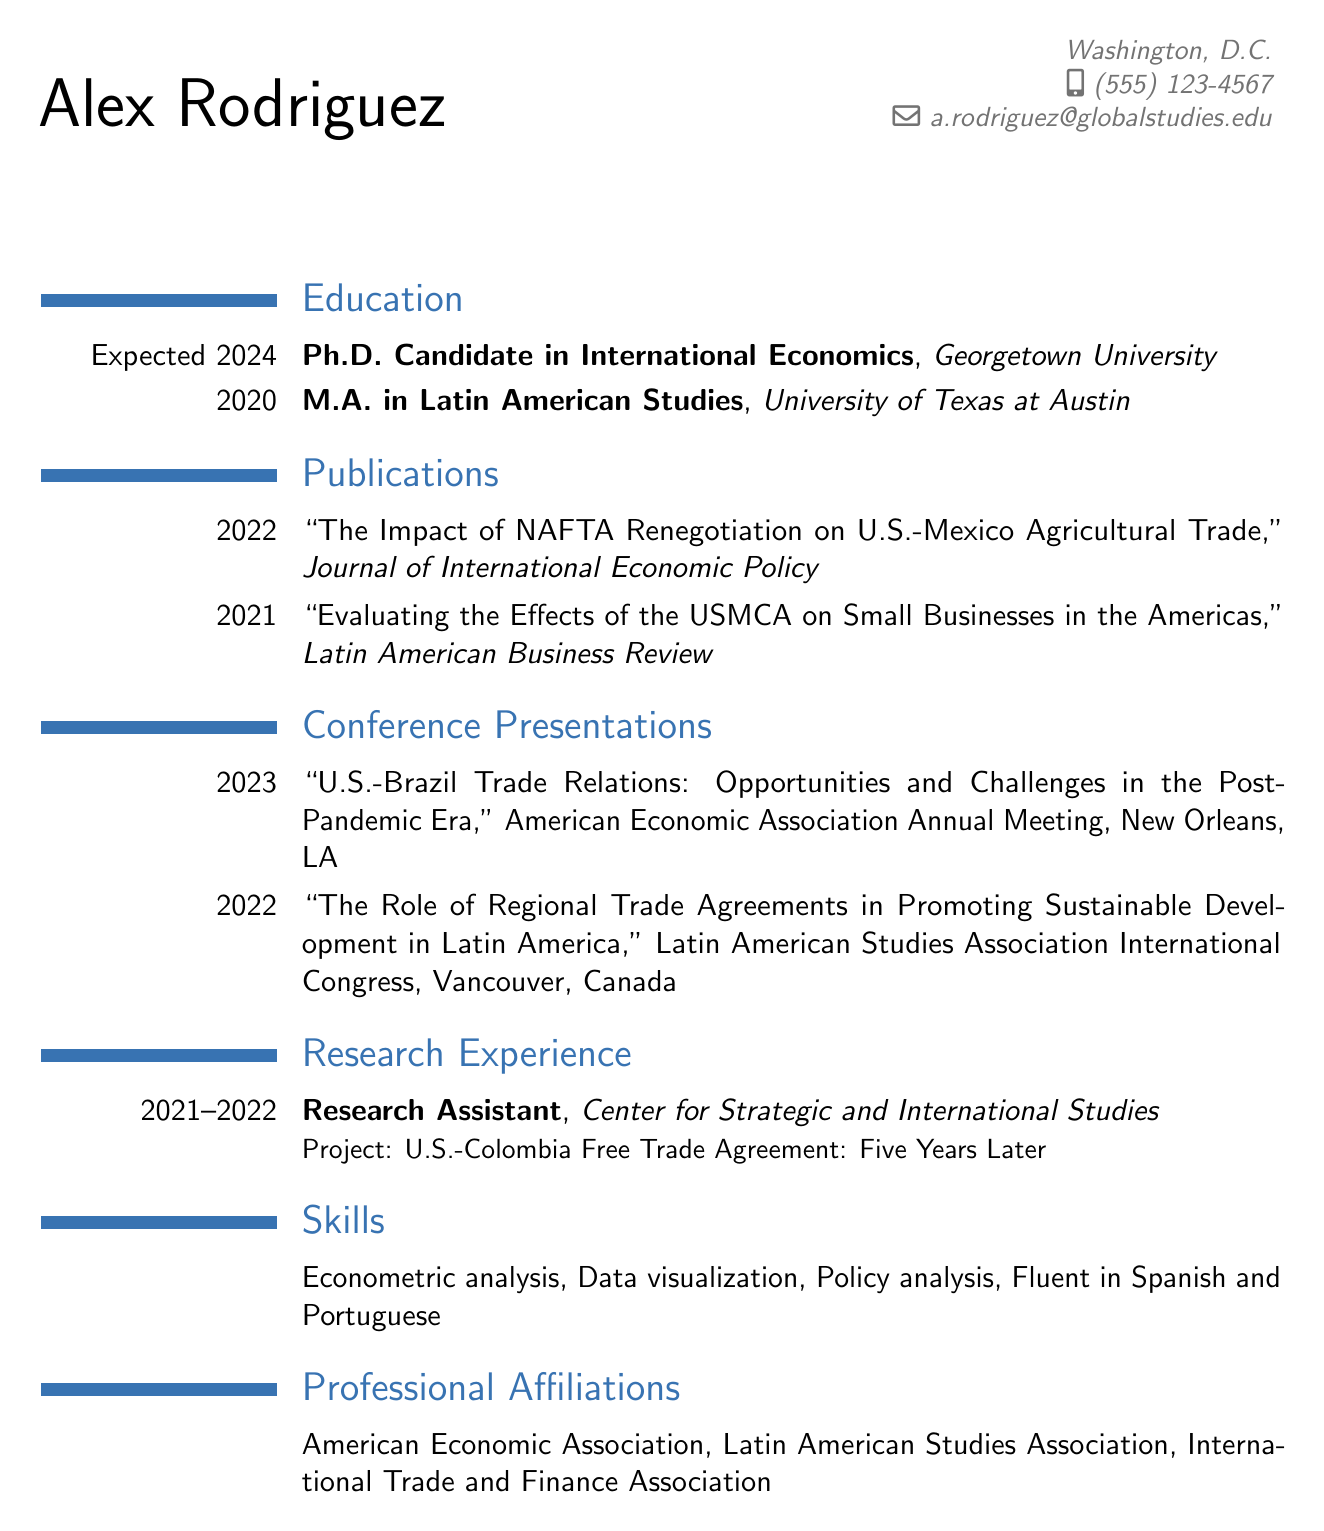What is the name of the candidate? The name is presented at the top of the document under personal information.
Answer: Alex Rodriguez What is the expected year of Ph.D. completion? The education section specifies the expected graduation date for the Ph.D. program.
Answer: 2024 How many publications are listed in the document? The publications section counts the number of distinct publication entries.
Answer: 2 What is the title of the 2022 publication? The publication title is provided in the publication section with the corresponding year.
Answer: The Impact of NAFTA Renegotiation on U.S.-Mexico Agricultural Trade Where was the 2023 conference presentation held? The location of the conference presentation is included in the conference presentations section.
Answer: New Orleans, LA What position did Alex Rodriguez hold at the Center for Strategic and International Studies? The research experience section describes the candidate's role at the organization.
Answer: Research Assistant Which language skills are mentioned in the resume? The skills section lists the candidate's language proficiency.
Answer: Fluent in Spanish and Portuguese Which professional organization is Alex affiliated with that focuses on economics? The professional affiliations section contains multiple associations, including one that deals with economics.
Answer: American Economic Association 